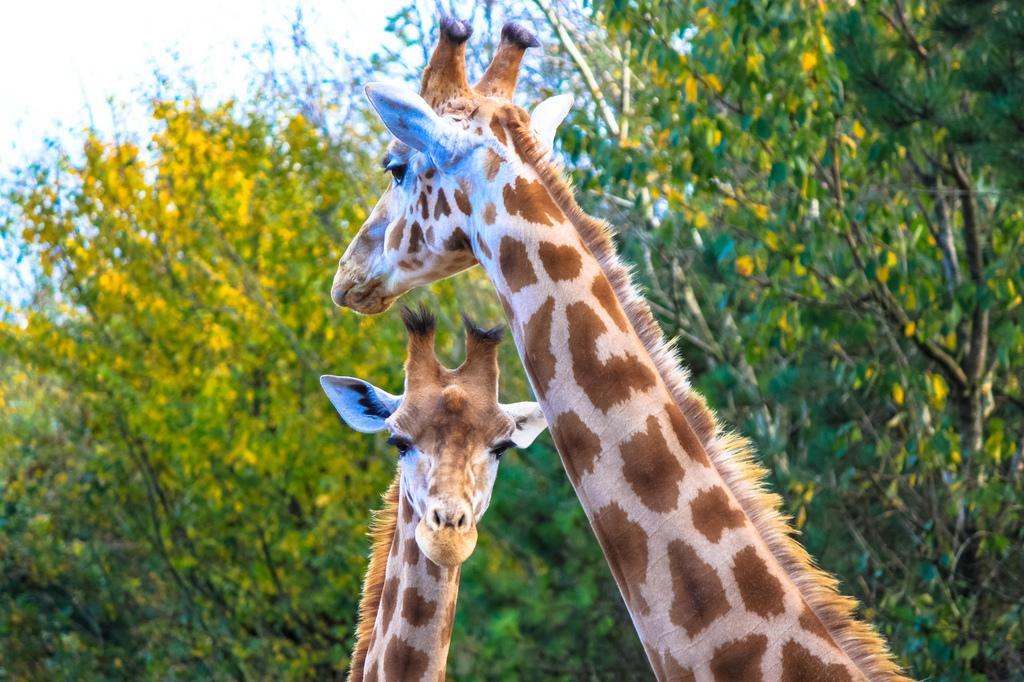Describe this image in one or two sentences. In this image we can see two giraffes, there are trees, at the top we can see the sky. 